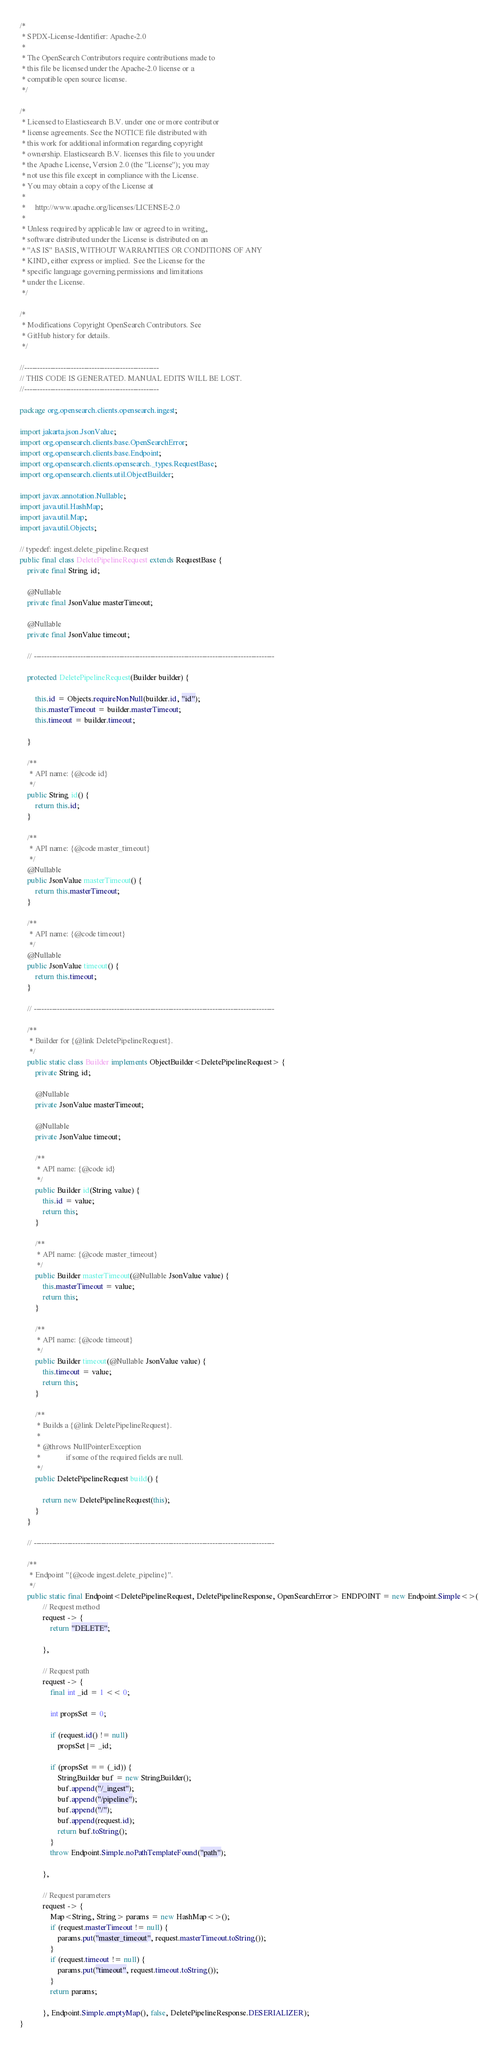<code> <loc_0><loc_0><loc_500><loc_500><_Java_>/*
 * SPDX-License-Identifier: Apache-2.0
 *
 * The OpenSearch Contributors require contributions made to
 * this file be licensed under the Apache-2.0 license or a
 * compatible open source license.
 */

/*
 * Licensed to Elasticsearch B.V. under one or more contributor
 * license agreements. See the NOTICE file distributed with
 * this work for additional information regarding copyright
 * ownership. Elasticsearch B.V. licenses this file to you under
 * the Apache License, Version 2.0 (the "License"); you may
 * not use this file except in compliance with the License.
 * You may obtain a copy of the License at
 *
 *     http://www.apache.org/licenses/LICENSE-2.0
 *
 * Unless required by applicable law or agreed to in writing,
 * software distributed under the License is distributed on an
 * "AS IS" BASIS, WITHOUT WARRANTIES OR CONDITIONS OF ANY
 * KIND, either express or implied.  See the License for the
 * specific language governing permissions and limitations
 * under the License.
 */

/*
 * Modifications Copyright OpenSearch Contributors. See
 * GitHub history for details.
 */

//----------------------------------------------------
// THIS CODE IS GENERATED. MANUAL EDITS WILL BE LOST.
//----------------------------------------------------

package org.opensearch.clients.opensearch.ingest;

import jakarta.json.JsonValue;
import org.opensearch.clients.base.OpenSearchError;
import org.opensearch.clients.base.Endpoint;
import org.opensearch.clients.opensearch._types.RequestBase;
import org.opensearch.clients.util.ObjectBuilder;

import javax.annotation.Nullable;
import java.util.HashMap;
import java.util.Map;
import java.util.Objects;

// typedef: ingest.delete_pipeline.Request
public final class DeletePipelineRequest extends RequestBase {
	private final String id;

	@Nullable
	private final JsonValue masterTimeout;

	@Nullable
	private final JsonValue timeout;

	// ---------------------------------------------------------------------------------------------

	protected DeletePipelineRequest(Builder builder) {

		this.id = Objects.requireNonNull(builder.id, "id");
		this.masterTimeout = builder.masterTimeout;
		this.timeout = builder.timeout;

	}

	/**
	 * API name: {@code id}
	 */
	public String id() {
		return this.id;
	}

	/**
	 * API name: {@code master_timeout}
	 */
	@Nullable
	public JsonValue masterTimeout() {
		return this.masterTimeout;
	}

	/**
	 * API name: {@code timeout}
	 */
	@Nullable
	public JsonValue timeout() {
		return this.timeout;
	}

	// ---------------------------------------------------------------------------------------------

	/**
	 * Builder for {@link DeletePipelineRequest}.
	 */
	public static class Builder implements ObjectBuilder<DeletePipelineRequest> {
		private String id;

		@Nullable
		private JsonValue masterTimeout;

		@Nullable
		private JsonValue timeout;

		/**
		 * API name: {@code id}
		 */
		public Builder id(String value) {
			this.id = value;
			return this;
		}

		/**
		 * API name: {@code master_timeout}
		 */
		public Builder masterTimeout(@Nullable JsonValue value) {
			this.masterTimeout = value;
			return this;
		}

		/**
		 * API name: {@code timeout}
		 */
		public Builder timeout(@Nullable JsonValue value) {
			this.timeout = value;
			return this;
		}

		/**
		 * Builds a {@link DeletePipelineRequest}.
		 *
		 * @throws NullPointerException
		 *             if some of the required fields are null.
		 */
		public DeletePipelineRequest build() {

			return new DeletePipelineRequest(this);
		}
	}

	// ---------------------------------------------------------------------------------------------

	/**
	 * Endpoint "{@code ingest.delete_pipeline}".
	 */
	public static final Endpoint<DeletePipelineRequest, DeletePipelineResponse, OpenSearchError> ENDPOINT = new Endpoint.Simple<>(
			// Request method
			request -> {
				return "DELETE";

			},

			// Request path
			request -> {
				final int _id = 1 << 0;

				int propsSet = 0;

				if (request.id() != null)
					propsSet |= _id;

				if (propsSet == (_id)) {
					StringBuilder buf = new StringBuilder();
					buf.append("/_ingest");
					buf.append("/pipeline");
					buf.append("/");
					buf.append(request.id);
					return buf.toString();
				}
				throw Endpoint.Simple.noPathTemplateFound("path");

			},

			// Request parameters
			request -> {
				Map<String, String> params = new HashMap<>();
				if (request.masterTimeout != null) {
					params.put("master_timeout", request.masterTimeout.toString());
				}
				if (request.timeout != null) {
					params.put("timeout", request.timeout.toString());
				}
				return params;

			}, Endpoint.Simple.emptyMap(), false, DeletePipelineResponse.DESERIALIZER);
}
</code> 